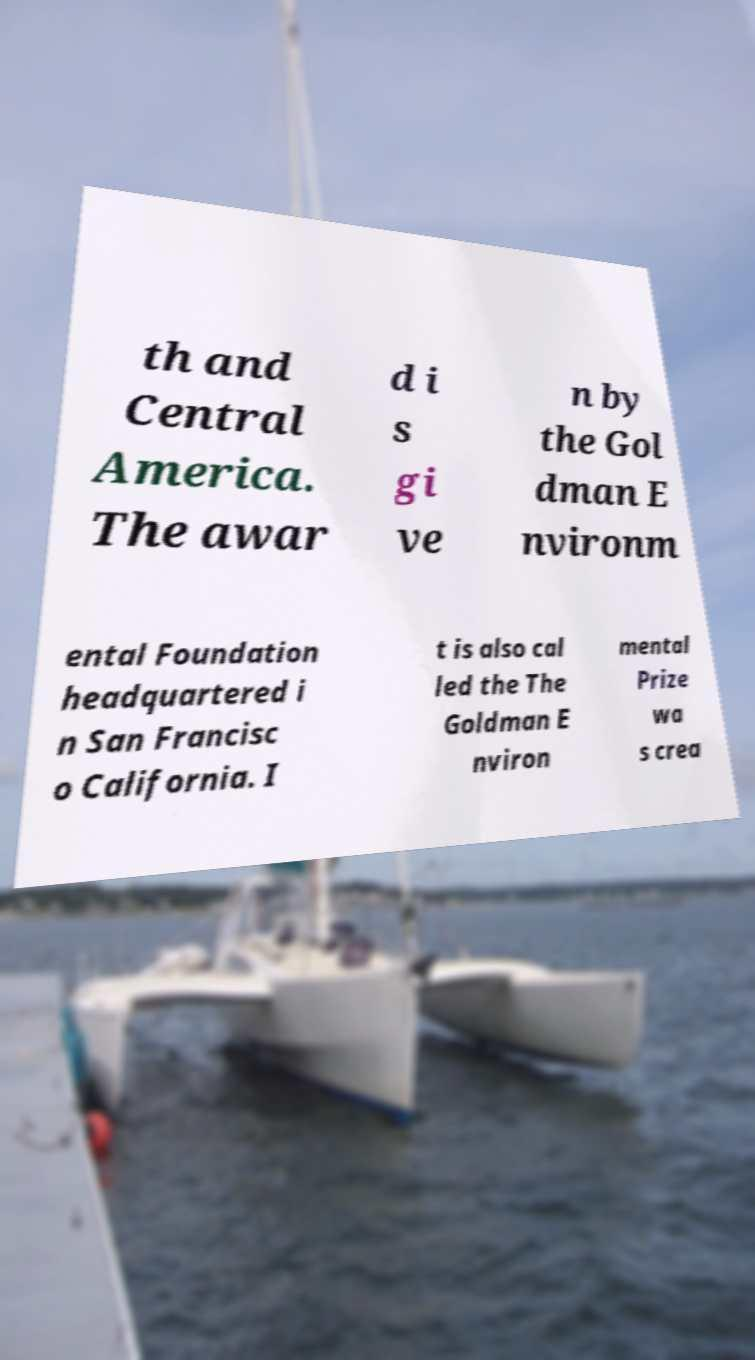What messages or text are displayed in this image? I need them in a readable, typed format. th and Central America. The awar d i s gi ve n by the Gol dman E nvironm ental Foundation headquartered i n San Francisc o California. I t is also cal led the The Goldman E nviron mental Prize wa s crea 